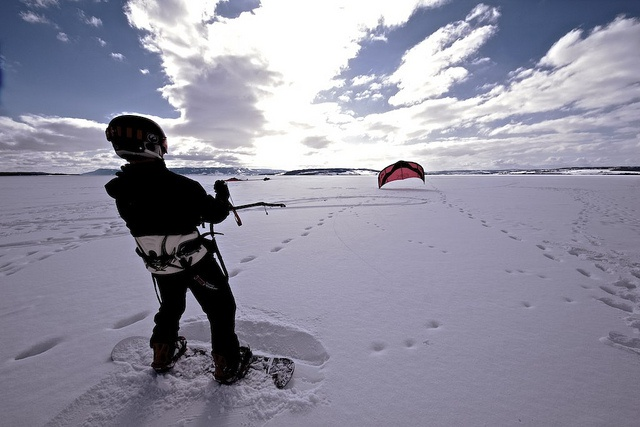Describe the objects in this image and their specific colors. I can see people in darkblue, black, gray, darkgray, and lavender tones, snowboard in darkblue, gray, and black tones, and kite in darkblue, black, brown, maroon, and lightgray tones in this image. 